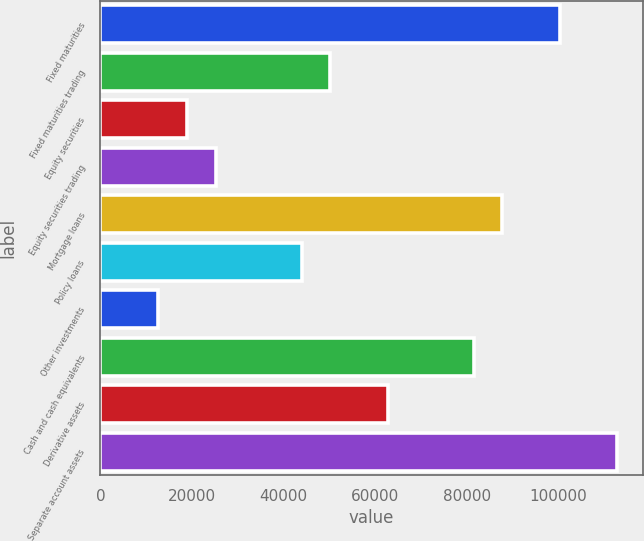Convert chart to OTSL. <chart><loc_0><loc_0><loc_500><loc_500><bar_chart><fcel>Fixed maturities<fcel>Fixed maturities trading<fcel>Equity securities<fcel>Equity securities trading<fcel>Mortgage loans<fcel>Policy loans<fcel>Other investments<fcel>Cash and cash equivalents<fcel>Derivative assets<fcel>Separate account assets<nl><fcel>100322<fcel>50210.6<fcel>18891<fcel>25154.9<fcel>87794.2<fcel>43946.7<fcel>12627.1<fcel>81530.3<fcel>62738.5<fcel>112850<nl></chart> 